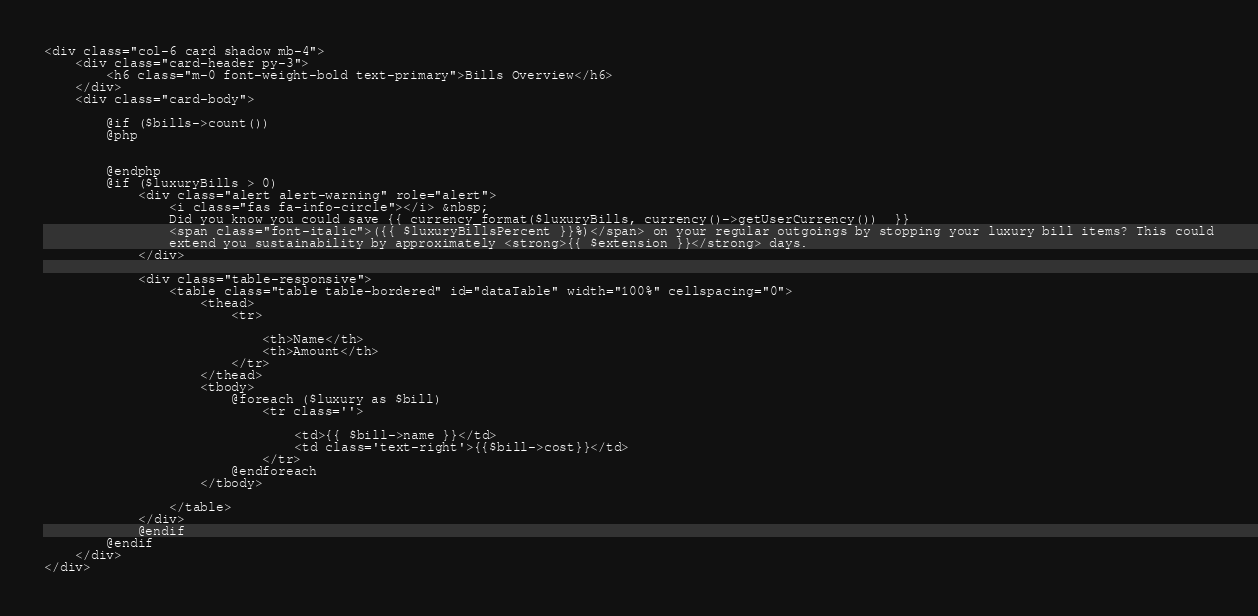<code> <loc_0><loc_0><loc_500><loc_500><_PHP_><div class="col-6 card shadow mb-4">
    <div class="card-header py-3">
        <h6 class="m-0 font-weight-bold text-primary">Bills Overview</h6>
    </div>
    <div class="card-body">

        @if ($bills->count())
        @php

        
        @endphp
        @if ($luxuryBills > 0)
            <div class="alert alert-warning" role="alert">
                <i class="fas fa-info-circle"></i> &nbsp;
                Did you know you could save {{ currency_format($luxuryBills, currency()->getUserCurrency())  }}
                <span class="font-italic">({{ $luxuryBillsPercent }}%)</span> on your regular outgoings by stopping your luxury bill items? This could
                extend you sustainability by approximately <strong>{{ $extension }}</strong> days.
            </div>

            <div class="table-responsive">
                <table class="table table-bordered" id="dataTable" width="100%" cellspacing="0">
                    <thead>
                        <tr>
                            
                            <th>Name</th>
                            <th>Amount</th>
                        </tr>
                    </thead>
                    <tbody>
                        @foreach ($luxury as $bill)
                            <tr class=''>
                               
                                <td>{{ $bill->name }}</td>
                                <td class='text-right'>{{$bill->cost}}</td>
                            </tr>
                        @endforeach
                    </tbody>

                </table>
            </div>
            @endif
        @endif
    </div>
</div></code> 